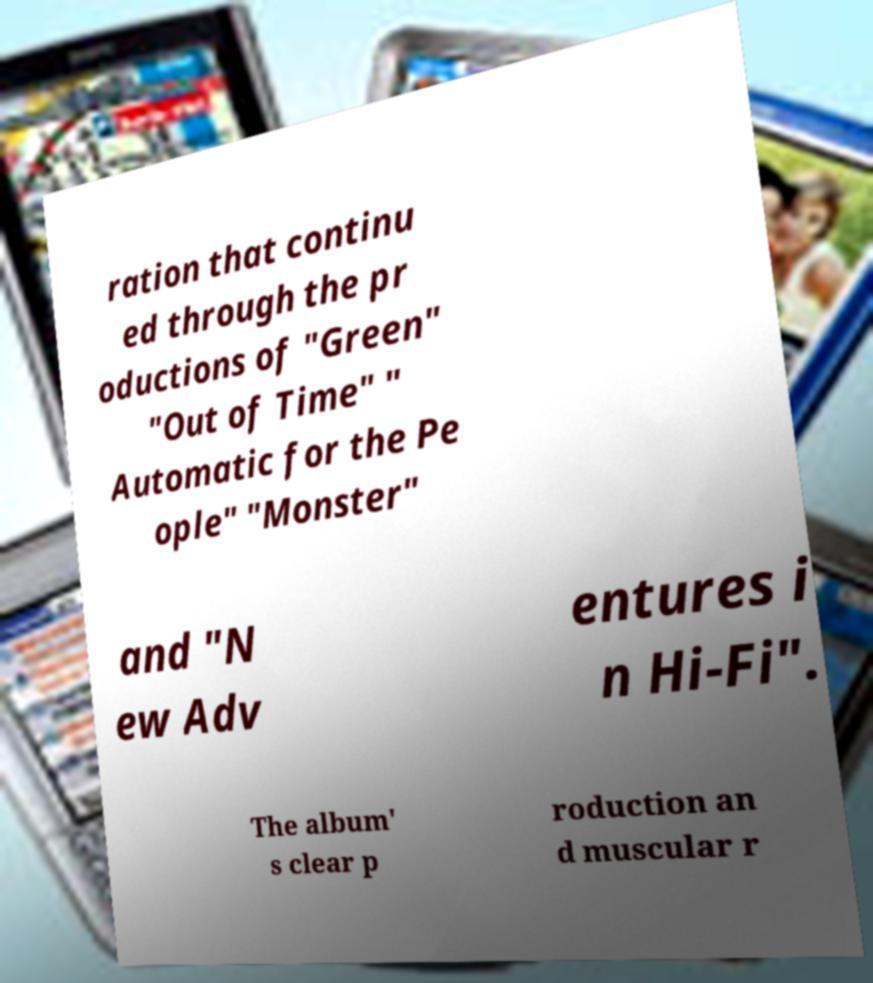Can you accurately transcribe the text from the provided image for me? ration that continu ed through the pr oductions of "Green" "Out of Time" " Automatic for the Pe ople" "Monster" and "N ew Adv entures i n Hi-Fi". The album' s clear p roduction an d muscular r 